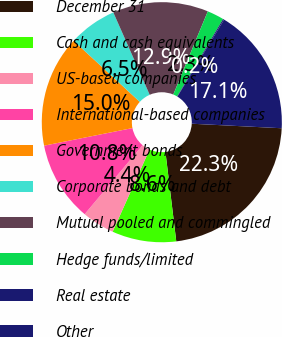Convert chart to OTSL. <chart><loc_0><loc_0><loc_500><loc_500><pie_chart><fcel>December 31<fcel>Cash and cash equivalents<fcel>US-based companies<fcel>International-based companies<fcel>Government bonds<fcel>Corporate bonds and debt<fcel>Mutual pooled and commingled<fcel>Hedge funds/limited<fcel>Real estate<fcel>Other<nl><fcel>22.28%<fcel>8.64%<fcel>4.39%<fcel>10.76%<fcel>15.0%<fcel>6.51%<fcel>12.88%<fcel>2.27%<fcel>0.15%<fcel>17.12%<nl></chart> 